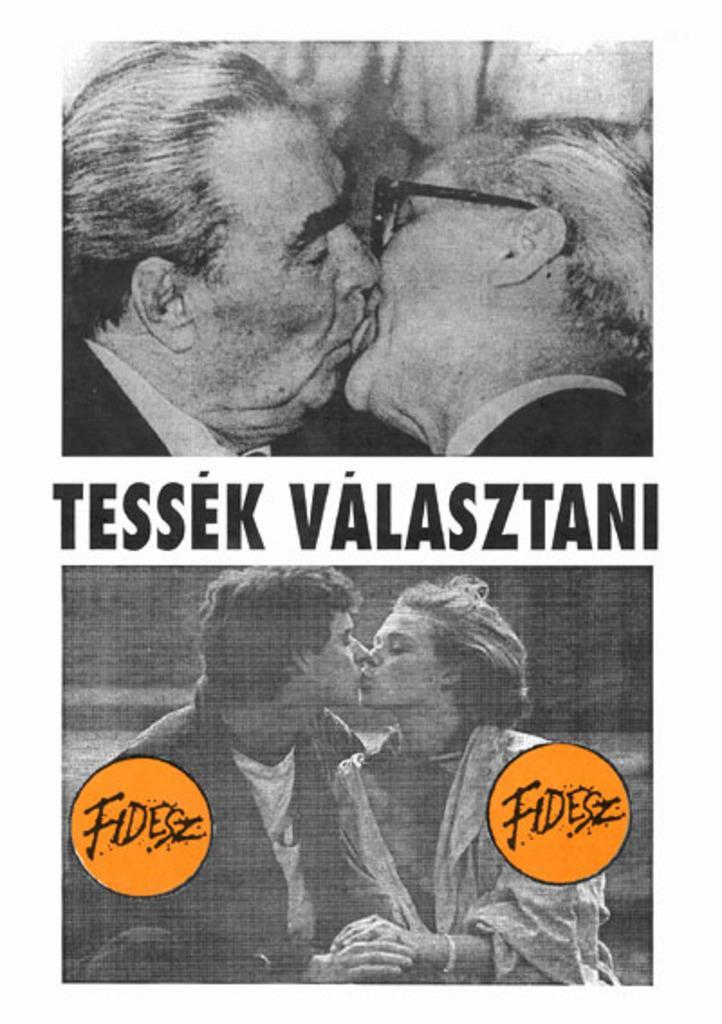Can you describe this image briefly? In this image I can see two persons sitting and kissing, and I can see something written on the image. 